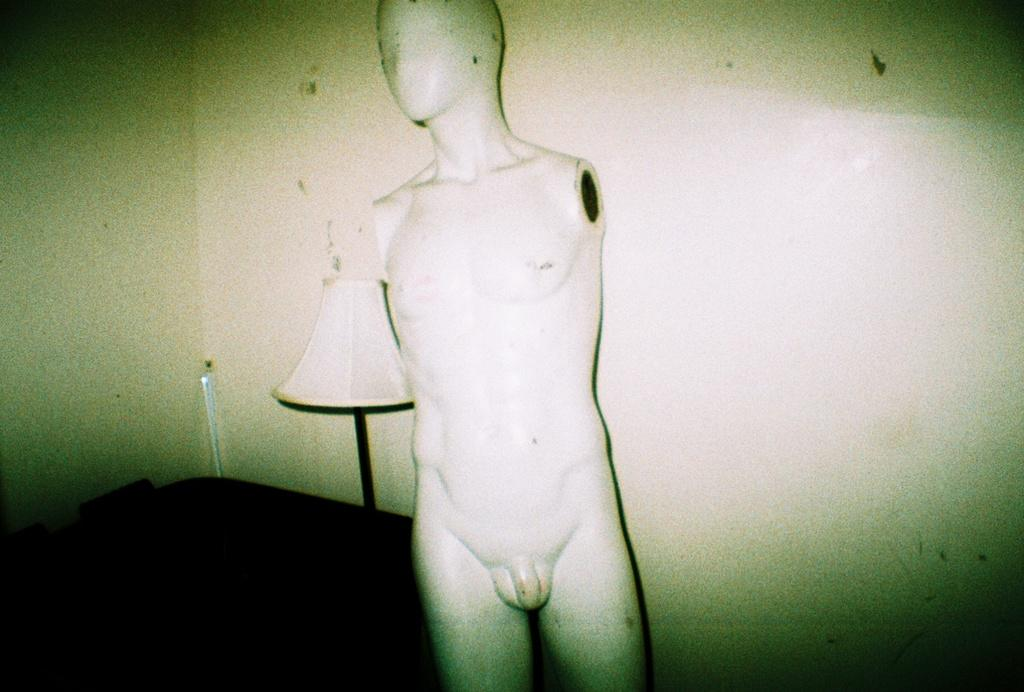What is the main object in the image? There is an object in the image, but the specific object is not mentioned in the facts. What type of figure can be seen in the image? There is a mannequin in the image. What is the source of light in the image? There is a lamp in the image. What can be seen in the background of the image? There are walls in the background of the image. What type of crime is being committed in the image? There is no indication of a crime being committed in the image. Can you provide an example of a similar object to the one in the image? Since the specific object in the image is not mentioned, it is impossible to provide an example of a similar object. 